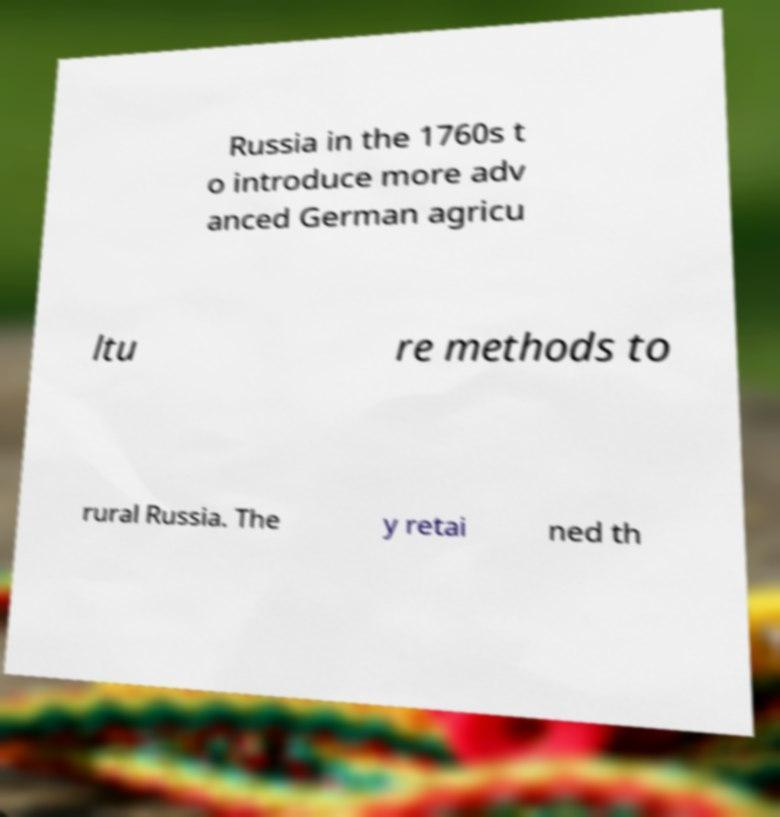What messages or text are displayed in this image? I need them in a readable, typed format. Russia in the 1760s t o introduce more adv anced German agricu ltu re methods to rural Russia. The y retai ned th 